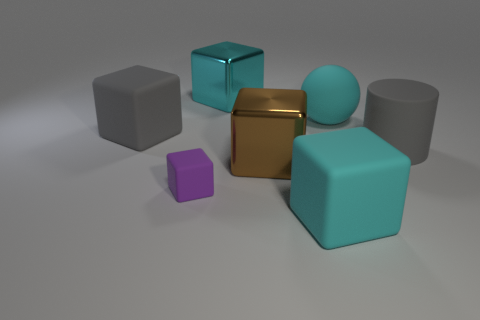Are there any large shiny objects of the same color as the sphere?
Provide a succinct answer. Yes. What shape is the cyan matte thing that is the same size as the cyan rubber cube?
Your response must be concise. Sphere. There is a big matte object that is on the left side of the purple matte thing; how many large cyan blocks are to the right of it?
Ensure brevity in your answer.  2. How many other things are there of the same material as the big gray cube?
Provide a succinct answer. 4. There is a shiny object behind the object that is on the left side of the tiny thing; what shape is it?
Provide a short and direct response. Cube. There is a metallic object behind the big cyan matte sphere; what is its size?
Make the answer very short. Large. Are the cylinder and the brown block made of the same material?
Offer a terse response. No. The big gray object that is made of the same material as the gray block is what shape?
Offer a terse response. Cylinder. Is there any other thing of the same color as the large sphere?
Your answer should be compact. Yes. The large rubber cube that is behind the cyan matte block is what color?
Ensure brevity in your answer.  Gray. 